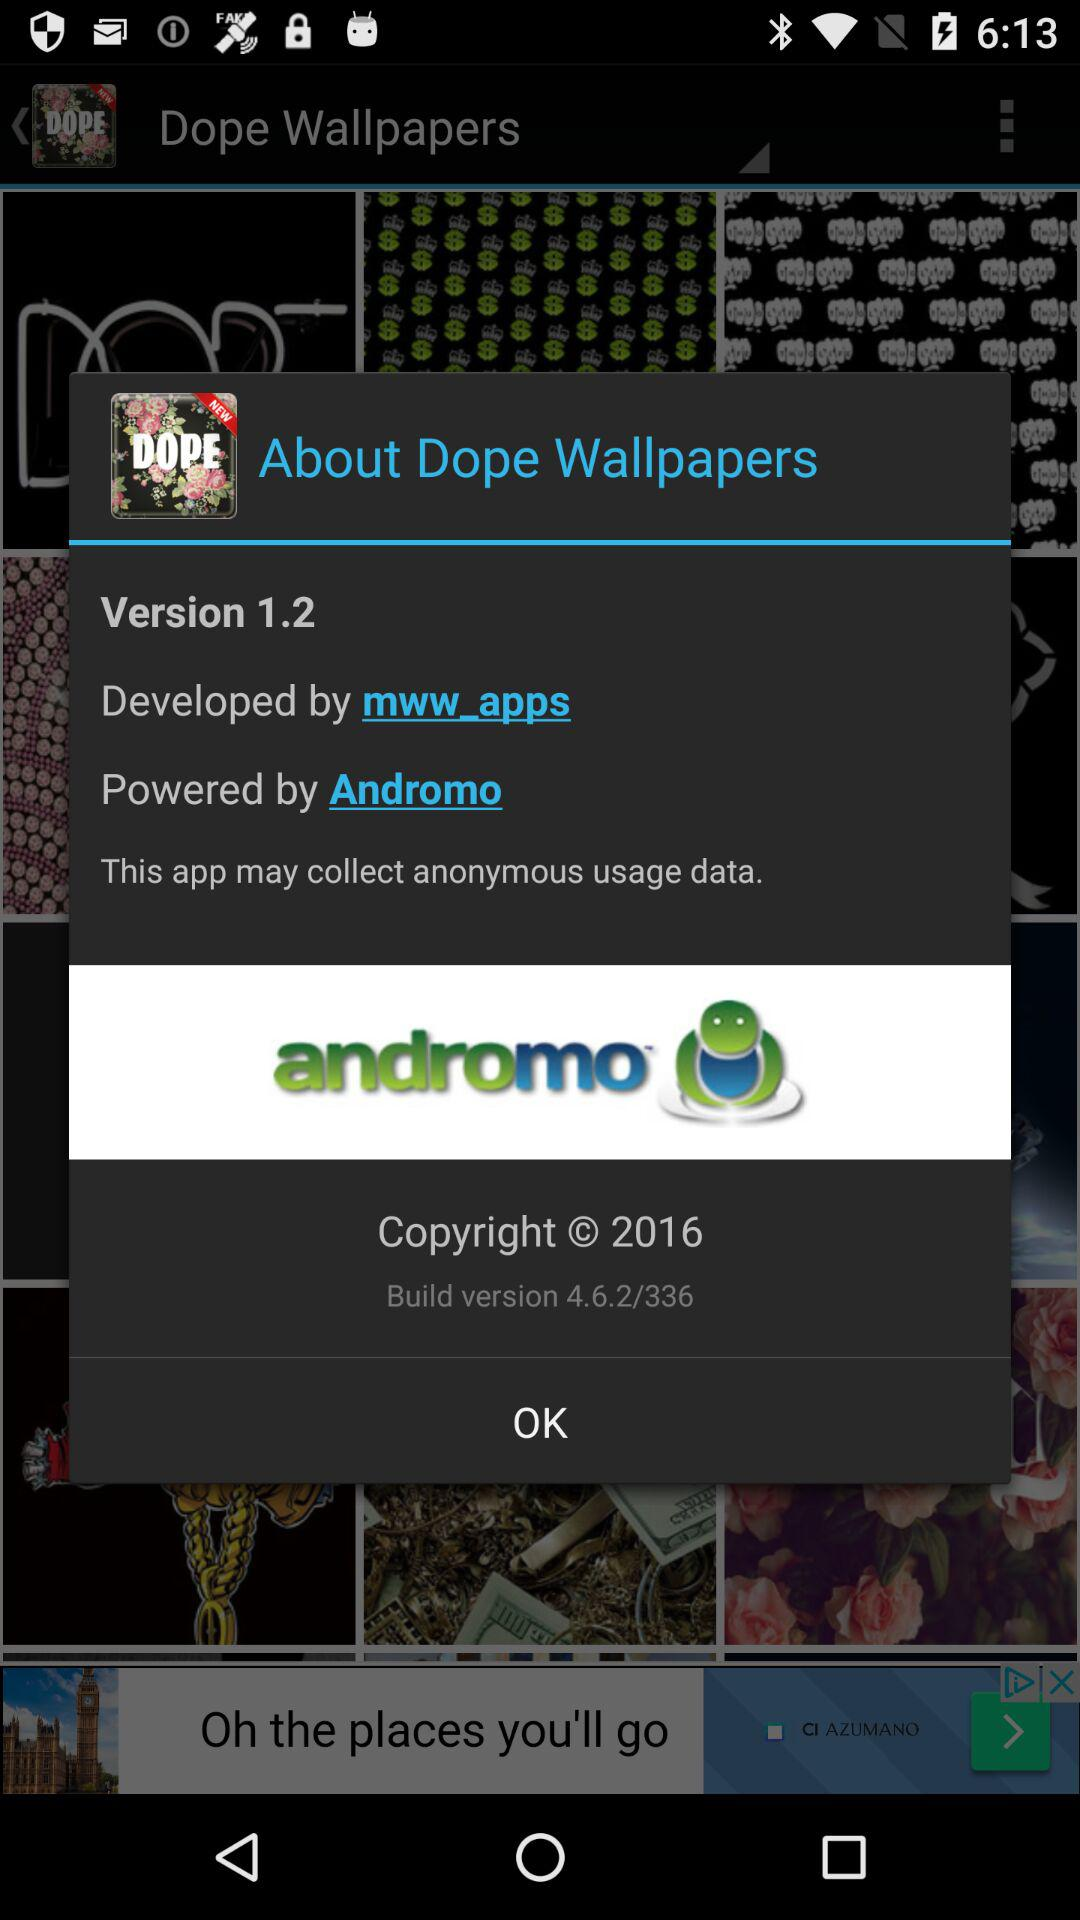What is the build version of "Dope Wallpapers" application? The build version of "Dope Wallpapers" application is 4.6.2/336. 